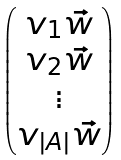Convert formula to latex. <formula><loc_0><loc_0><loc_500><loc_500>\begin{pmatrix} v _ { 1 } \vec { w } \\ v _ { 2 } \vec { w } \\ \vdots \\ v _ { | A | } \vec { w } \end{pmatrix}</formula> 